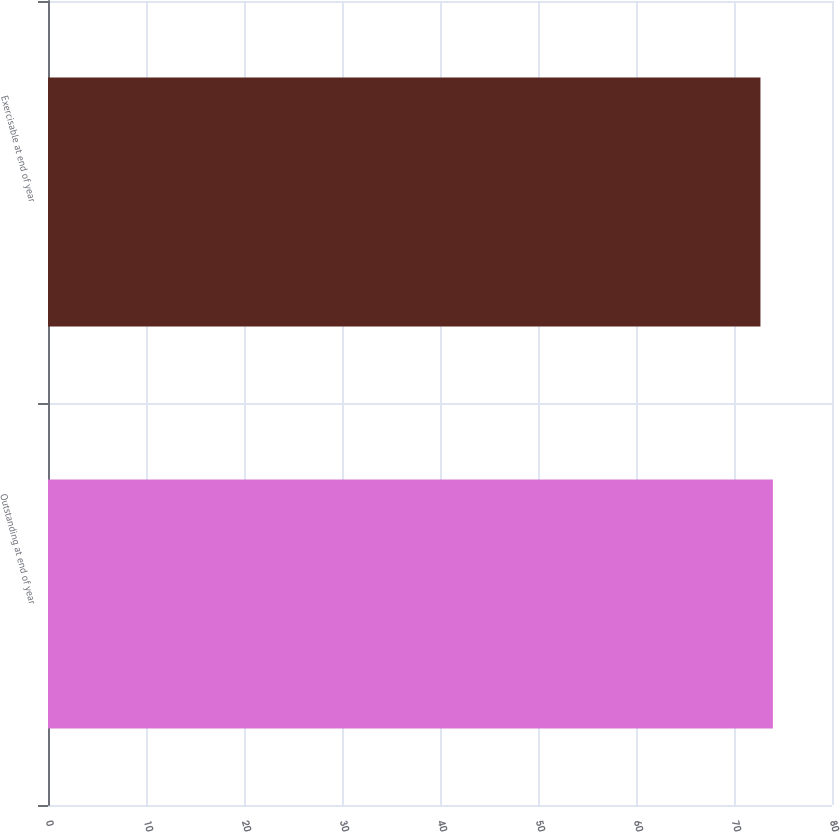Convert chart to OTSL. <chart><loc_0><loc_0><loc_500><loc_500><bar_chart><fcel>Outstanding at end of year<fcel>Exercisable at end of year<nl><fcel>73.97<fcel>72.7<nl></chart> 